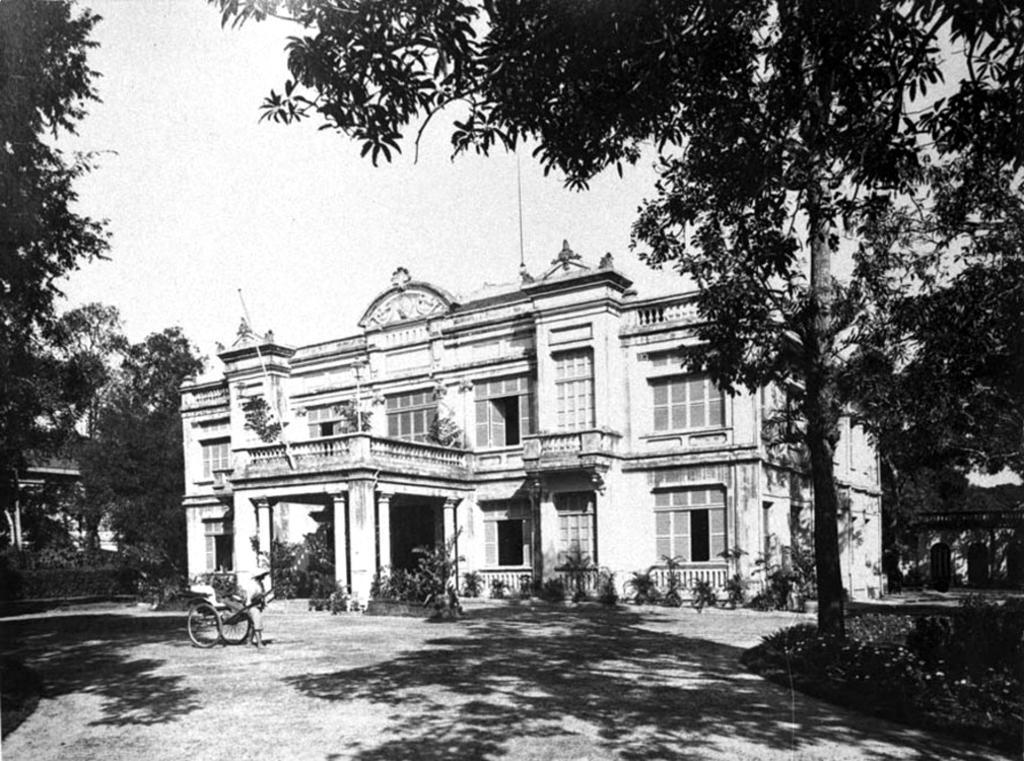In one or two sentences, can you explain what this image depicts? This is a black and white image. Here I can see a building, in front of this there are some plants and a vehicle. On the right and left side of the image I can see the trees. On the top of the image I can see the sky. 